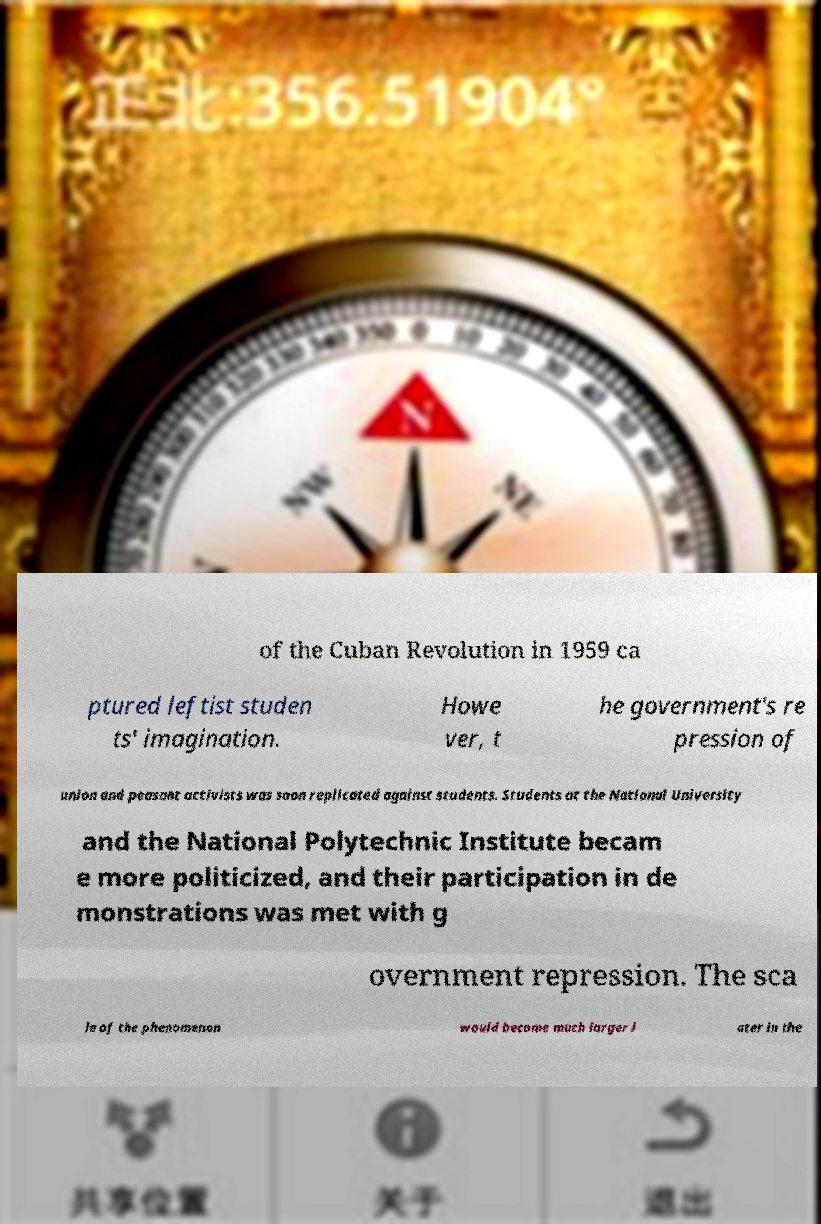I need the written content from this picture converted into text. Can you do that? of the Cuban Revolution in 1959 ca ptured leftist studen ts' imagination. Howe ver, t he government's re pression of union and peasant activists was soon replicated against students. Students at the National University and the National Polytechnic Institute becam e more politicized, and their participation in de monstrations was met with g overnment repression. The sca le of the phenomenon would become much larger l ater in the 